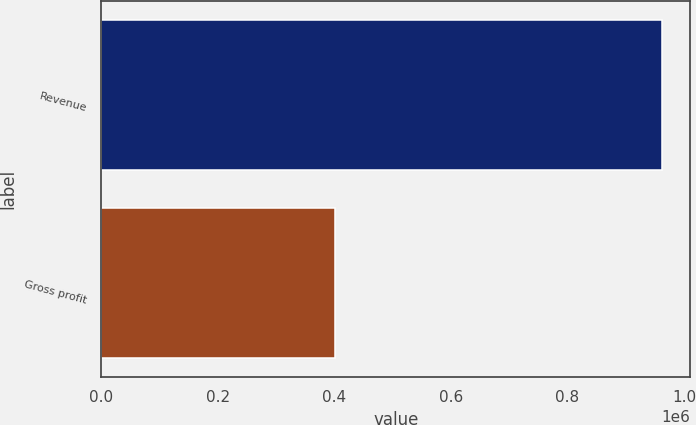<chart> <loc_0><loc_0><loc_500><loc_500><bar_chart><fcel>Revenue<fcel>Gross profit<nl><fcel>962729<fcel>400659<nl></chart> 